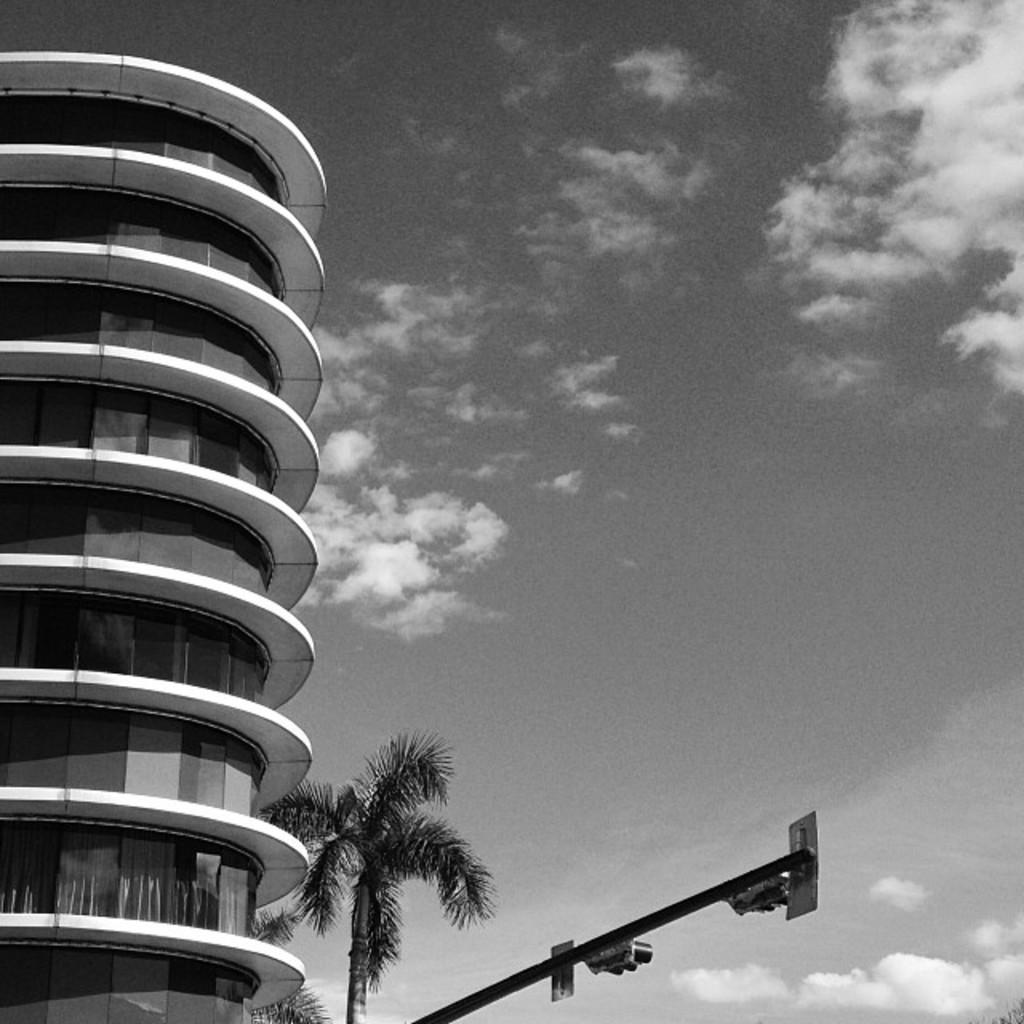What is the color scheme of the image? The image is black and white. What type of structure can be seen in the image? There is a building in the image. What other natural elements are present in the image? There are trees in the image. What type of traffic control device is present in the image? There are signal lights on a pole in the image. What can be seen in the background of the image? The sky is visible in the background of the image. Can you see any worms crawling on the building in the image? There are no worms present in the image; it features a building, trees, signal lights, and a black and white color scheme. 